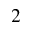Convert formula to latex. <formula><loc_0><loc_0><loc_500><loc_500>^ { 2 }</formula> 